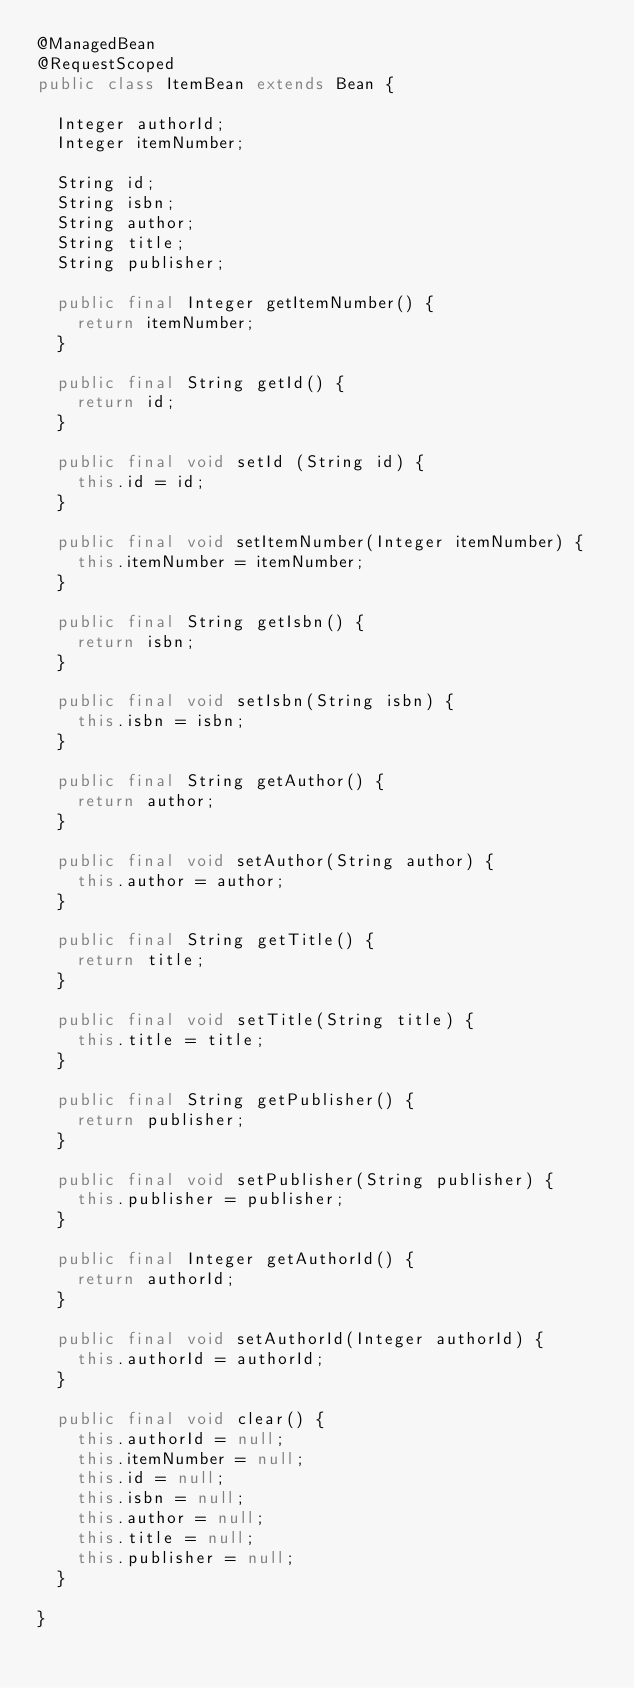Convert code to text. <code><loc_0><loc_0><loc_500><loc_500><_Java_>@ManagedBean
@RequestScoped
public class ItemBean extends Bean {

	Integer authorId;
	Integer itemNumber;
	
	String id;
	String isbn;
	String author;
	String title;
	String publisher;
	
	public final Integer getItemNumber() {
		return itemNumber;
	}

	public final String getId() {
		return id;
	}

	public final void setId (String id) {
		this.id = id;
	}

	public final void setItemNumber(Integer itemNumber) {
		this.itemNumber = itemNumber;
	}
	
	public final String getIsbn() {
		return isbn;
	}
	
	public final void setIsbn(String isbn) {
		this.isbn = isbn;
	}
	
	public final String getAuthor() {
		return author;
	}
	
	public final void setAuthor(String author) {
		this.author = author;
	}
	
	public final String getTitle() {
		return title;
	}
	
	public final void setTitle(String title) {
		this.title = title;
	}
	
	public final String getPublisher() {
		return publisher;
	}
	
	public final void setPublisher(String publisher) {
		this.publisher = publisher;
	}
		
	public final Integer getAuthorId() {
		return authorId;
	}

	public final void setAuthorId(Integer authorId) {
		this.authorId = authorId;
	}

	public final void clear() {
		this.authorId = null;
		this.itemNumber = null;
		this.id = null;
		this.isbn = null;
		this.author = null;
		this.title = null;
		this.publisher = null;
	}

}
</code> 